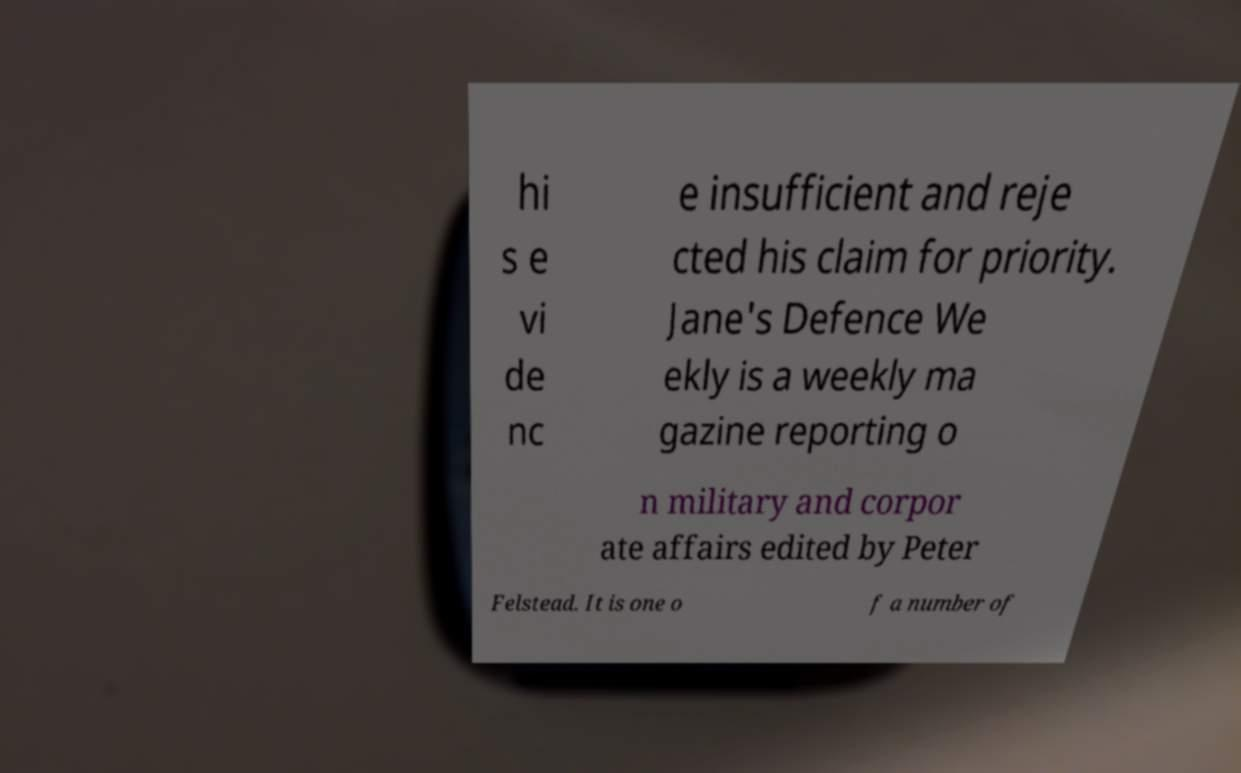Can you read and provide the text displayed in the image?This photo seems to have some interesting text. Can you extract and type it out for me? hi s e vi de nc e insufficient and reje cted his claim for priority. Jane's Defence We ekly is a weekly ma gazine reporting o n military and corpor ate affairs edited by Peter Felstead. It is one o f a number of 